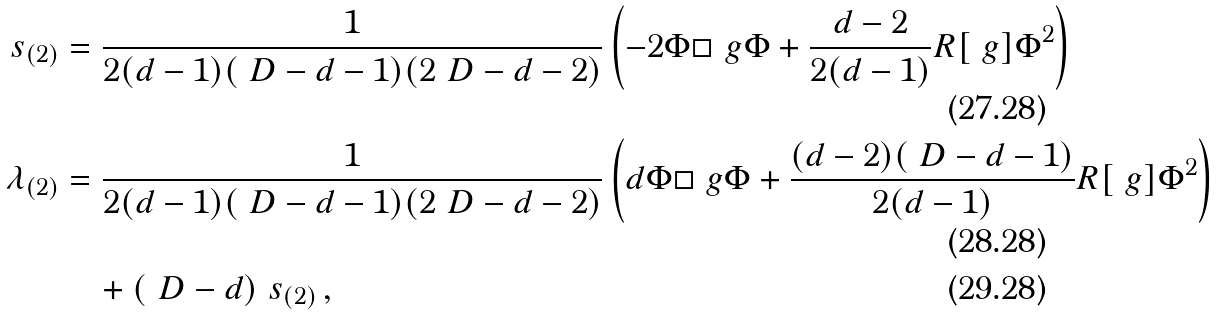<formula> <loc_0><loc_0><loc_500><loc_500>\ s _ { ( 2 ) } & = \frac { 1 } { 2 ( d - 1 ) ( \ D - d - 1 ) ( 2 \ D - d - 2 ) } \left ( - 2 \Phi \square _ { \ } g \Phi + \frac { d - 2 } { 2 ( d - 1 ) } R [ \ g ] \Phi ^ { 2 } \right ) \\ \lambda _ { ( 2 ) } & = \frac { 1 } { 2 ( d - 1 ) ( \ D - d - 1 ) ( 2 \ D - d - 2 ) } \left ( d \Phi \square _ { \ } g \Phi + \frac { ( d - 2 ) ( \ D - d - 1 ) } { 2 ( d - 1 ) } R [ \ g ] \Phi ^ { 2 } \right ) \\ & \quad + ( \ D - d ) \ s _ { ( 2 ) } \, ,</formula> 